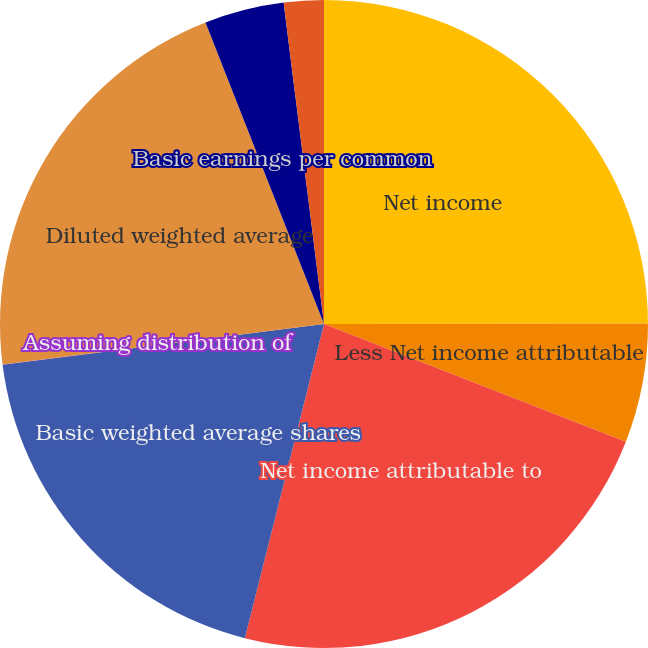<chart> <loc_0><loc_0><loc_500><loc_500><pie_chart><fcel>Net income<fcel>Less Net income attributable<fcel>Net income attributable to<fcel>Basic weighted average shares<fcel>Assuming distribution of<fcel>Diluted weighted average<fcel>Basic earnings per common<fcel>Diluted earnings per common<nl><fcel>24.98%<fcel>5.94%<fcel>23.01%<fcel>19.06%<fcel>0.02%<fcel>21.03%<fcel>3.97%<fcel>1.99%<nl></chart> 